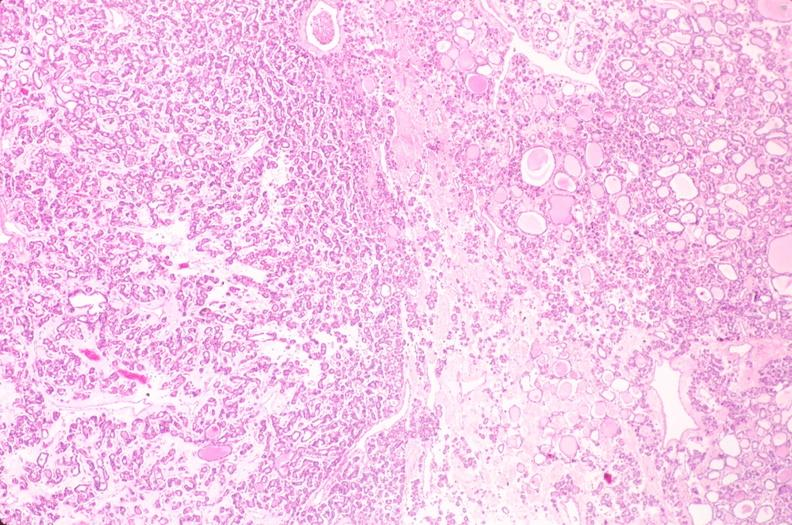does notochord show thyroid, nodular hyperplasia?
Answer the question using a single word or phrase. No 